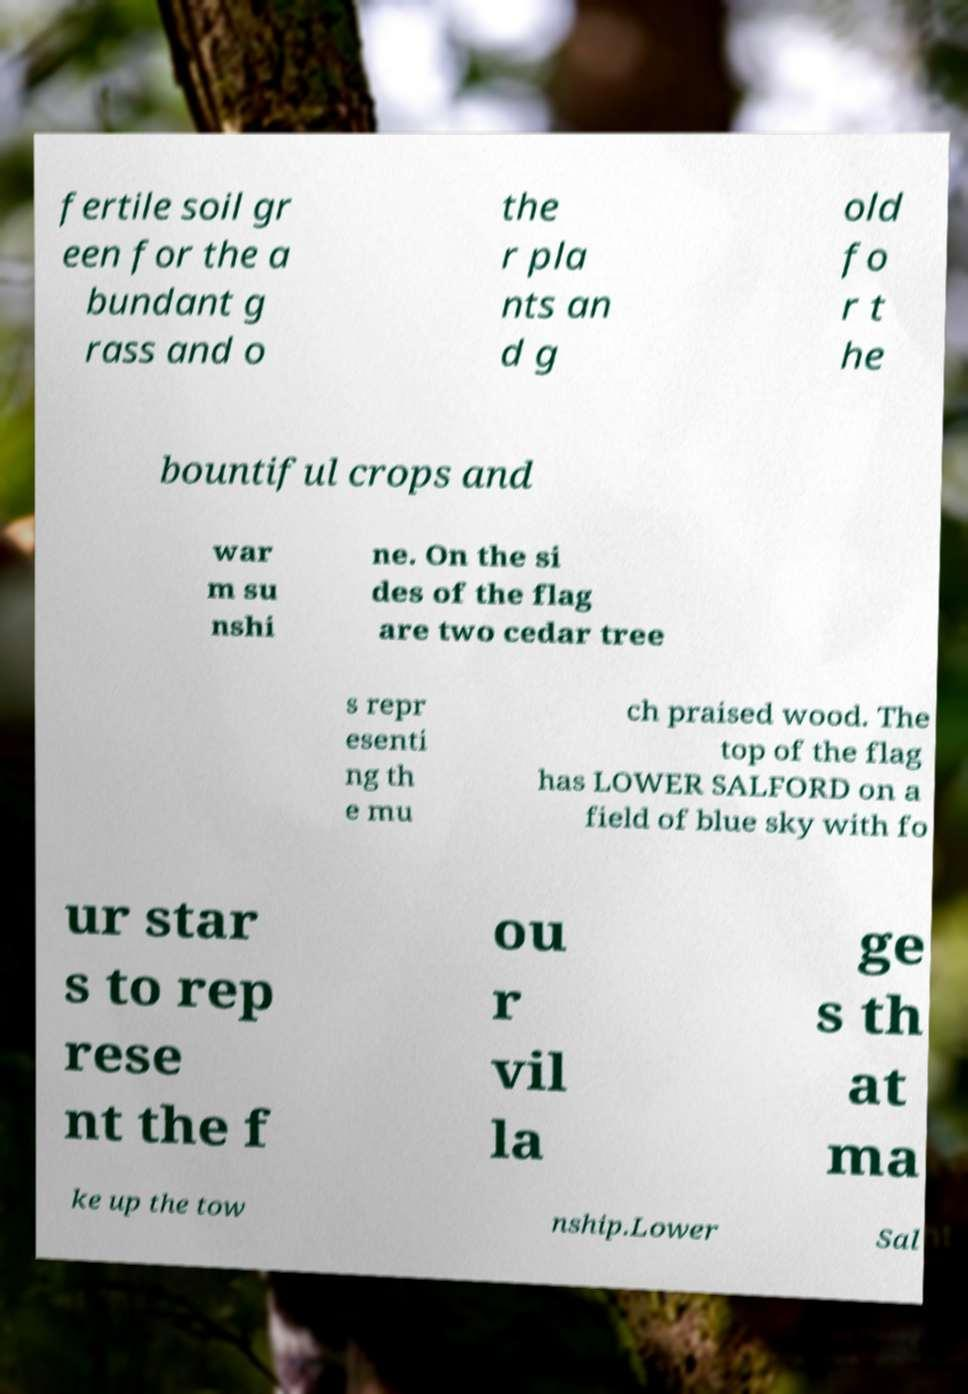What messages or text are displayed in this image? I need them in a readable, typed format. fertile soil gr een for the a bundant g rass and o the r pla nts an d g old fo r t he bountiful crops and war m su nshi ne. On the si des of the flag are two cedar tree s repr esenti ng th e mu ch praised wood. The top of the flag has LOWER SALFORD on a field of blue sky with fo ur star s to rep rese nt the f ou r vil la ge s th at ma ke up the tow nship.Lower Sal 